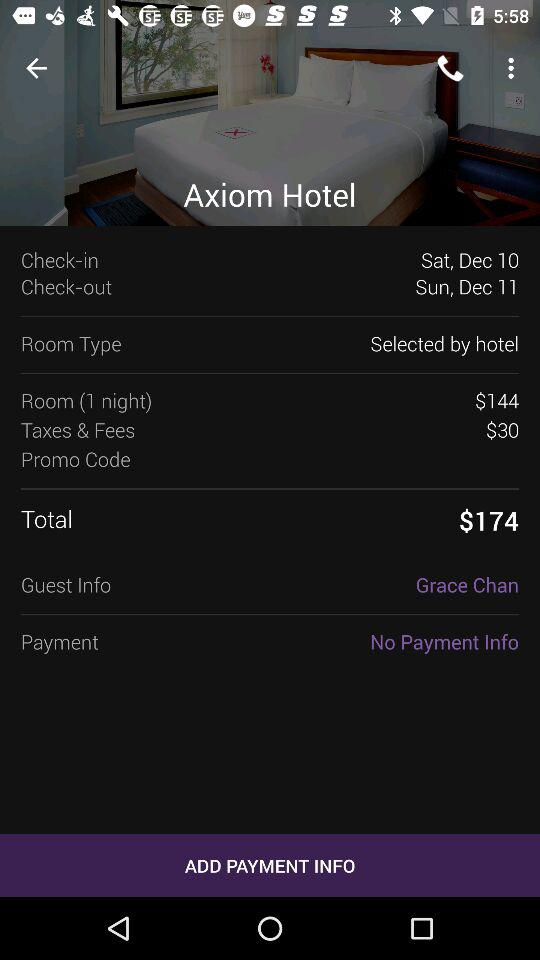How many days is the stay?
Answer the question using a single word or phrase. 1 